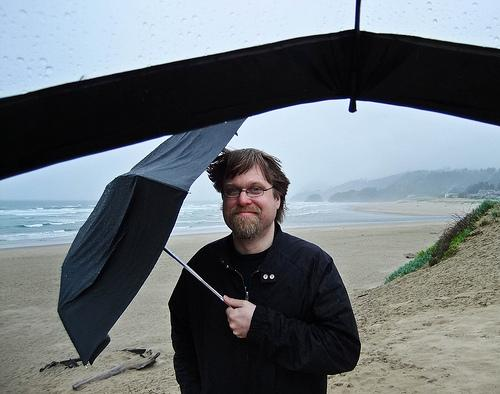Question: who is the man looking at?
Choices:
A. The girl.
B. The photographer.
C. The lady.
D. The man.
Answer with the letter. Answer: B Question: why does he have an umbrella?
Choices:
A. It's drizzling.
B. It's sprinkling.
C. It's pouring.
D. It's raining.
Answer with the letter. Answer: D Question: what color is the umbrella?
Choices:
A. Red.
B. Yellow.
C. Blue.
D. Gold.
Answer with the letter. Answer: C Question: where is the man standing?
Choices:
A. On a beach.
B. In line.
C. At the game.
D. On the train.
Answer with the letter. Answer: A Question: where are the man's eyeglasses?
Choices:
A. On his face.
B. In his pocket.
C. On the desk.
D. In the drawer.
Answer with the letter. Answer: A Question: what is on the window?
Choices:
A. Rain drops.
B. Picture.
C. Ornament.
D. Fly.
Answer with the letter. Answer: A 